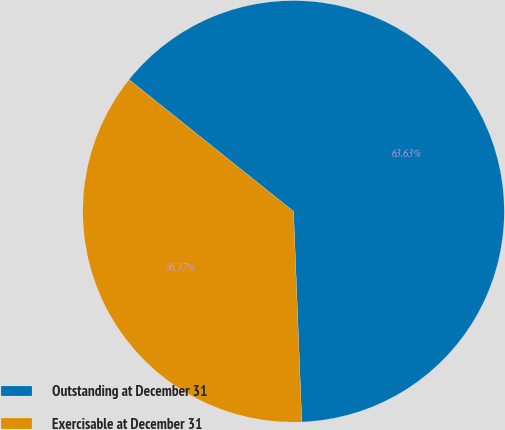<chart> <loc_0><loc_0><loc_500><loc_500><pie_chart><fcel>Outstanding at December 31<fcel>Exercisable at December 31<nl><fcel>63.63%<fcel>36.37%<nl></chart> 